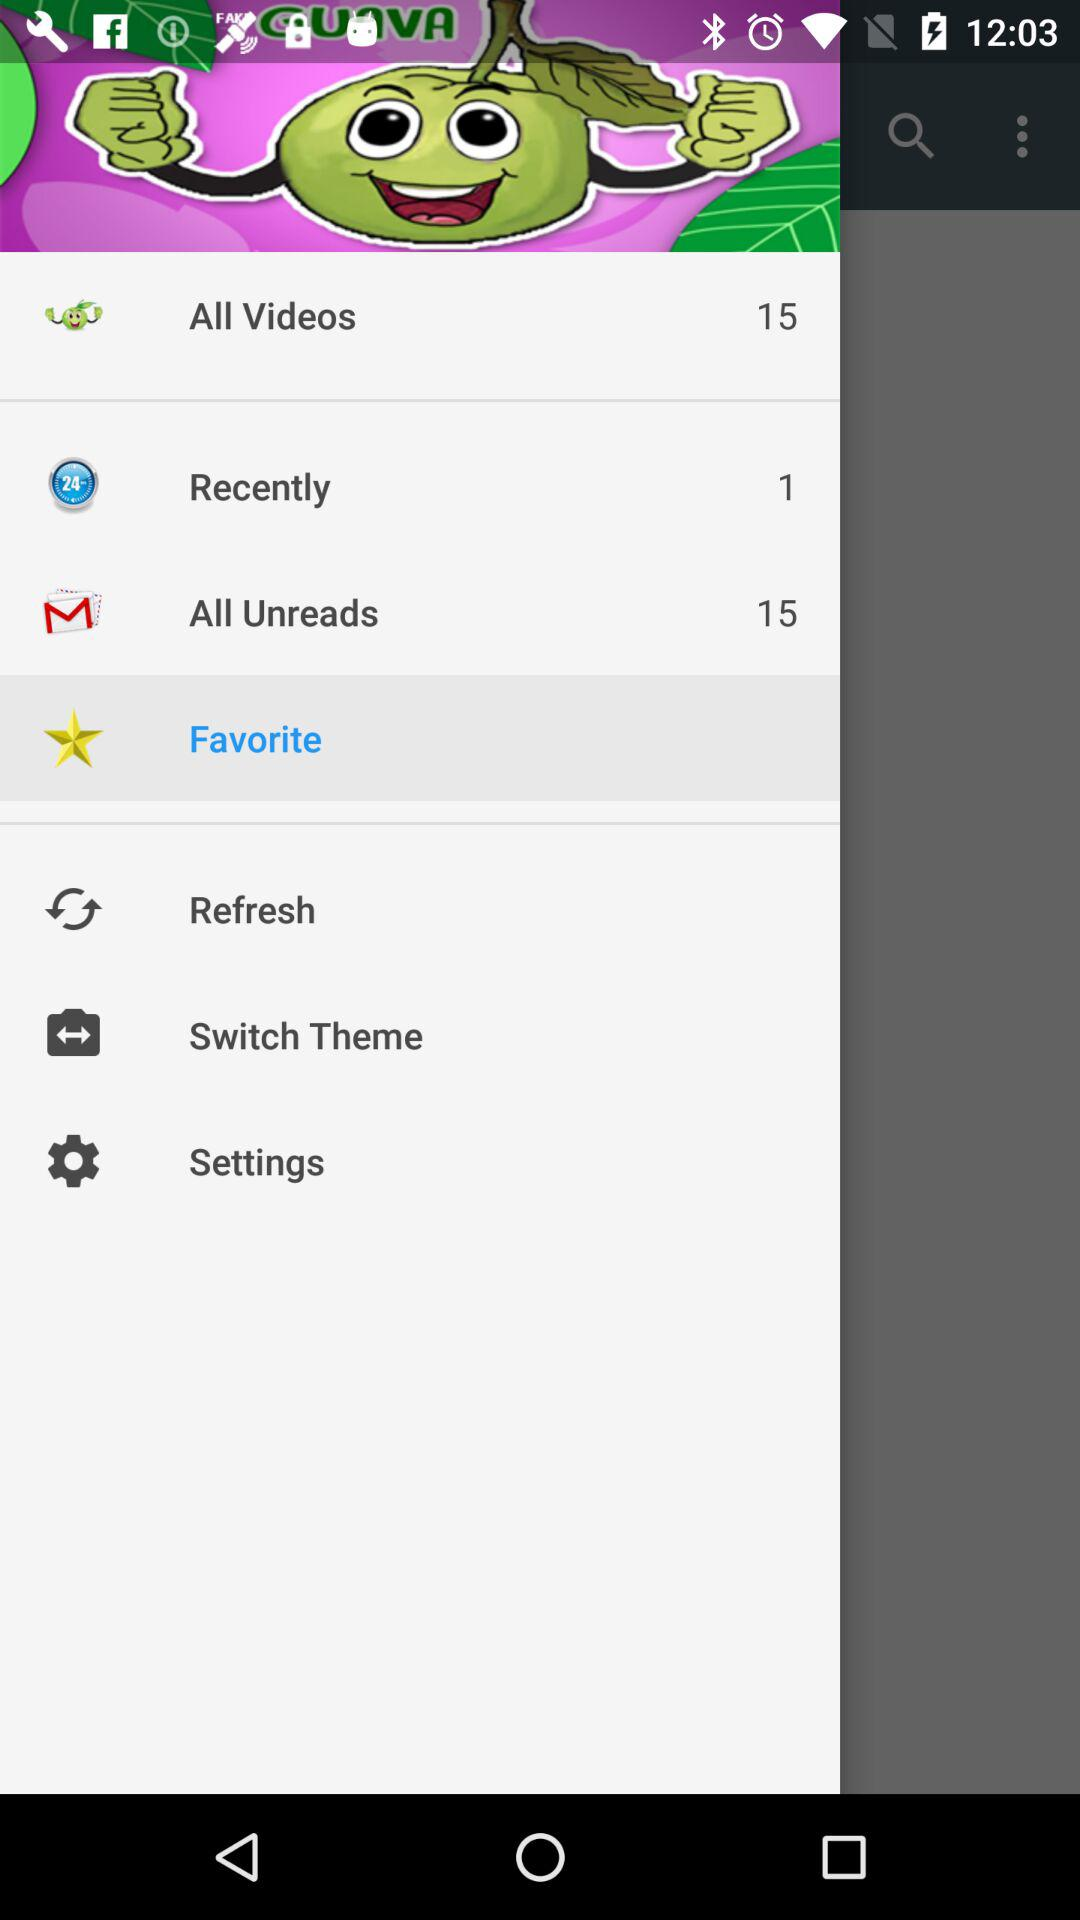How many items are there in "All Videos"? There are 15 items in "All Videos". 